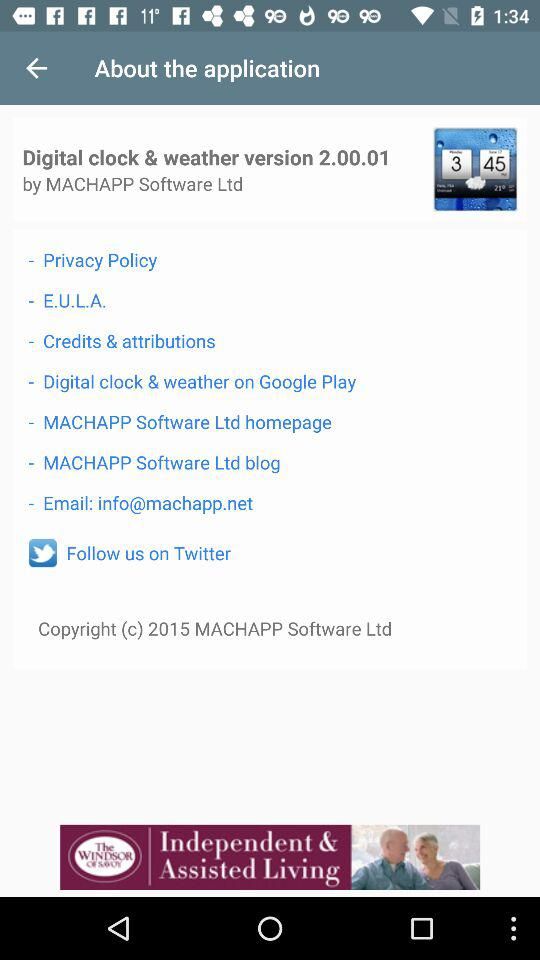By which software company was the application developed? The application was developed by "MACHAPP Software Ltd". 